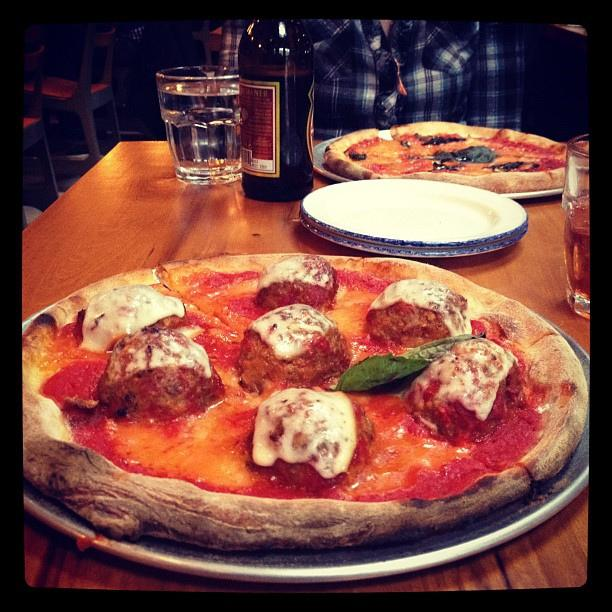The two pizzas have different sized what?

Choices:
A) plates
B) toppings
C) cheese
D) colors toppings 